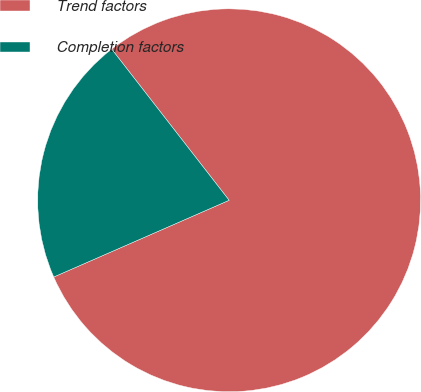Convert chart to OTSL. <chart><loc_0><loc_0><loc_500><loc_500><pie_chart><fcel>Trend factors<fcel>Completion factors<nl><fcel>78.95%<fcel>21.05%<nl></chart> 